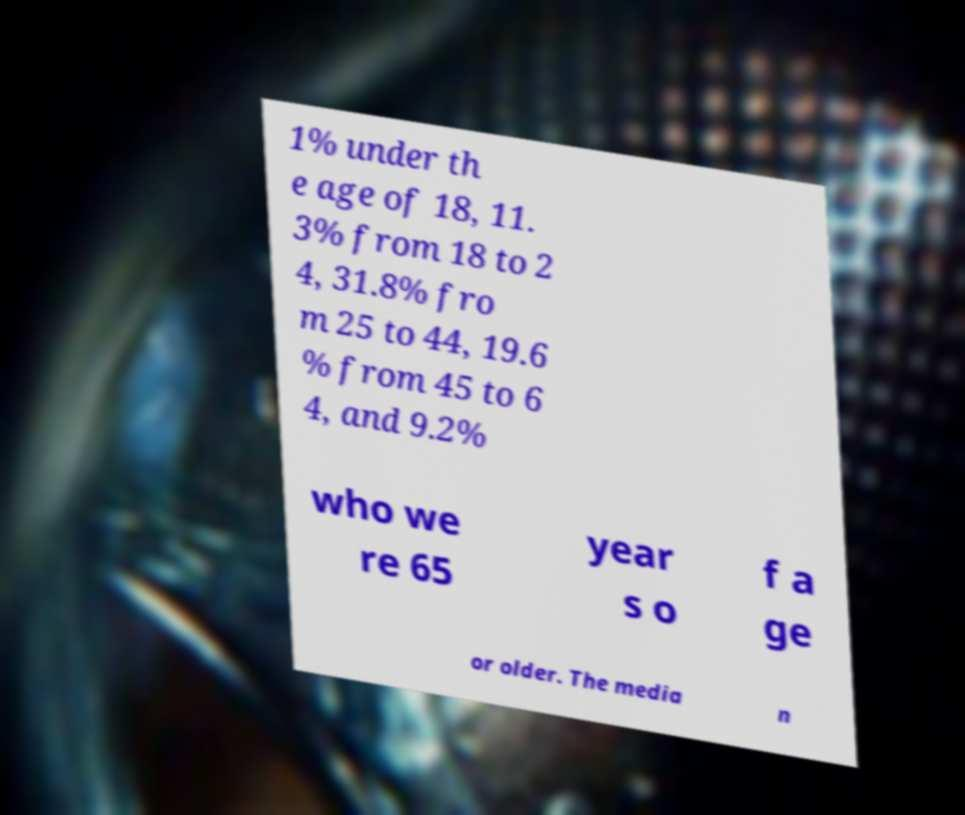I need the written content from this picture converted into text. Can you do that? 1% under th e age of 18, 11. 3% from 18 to 2 4, 31.8% fro m 25 to 44, 19.6 % from 45 to 6 4, and 9.2% who we re 65 year s o f a ge or older. The media n 